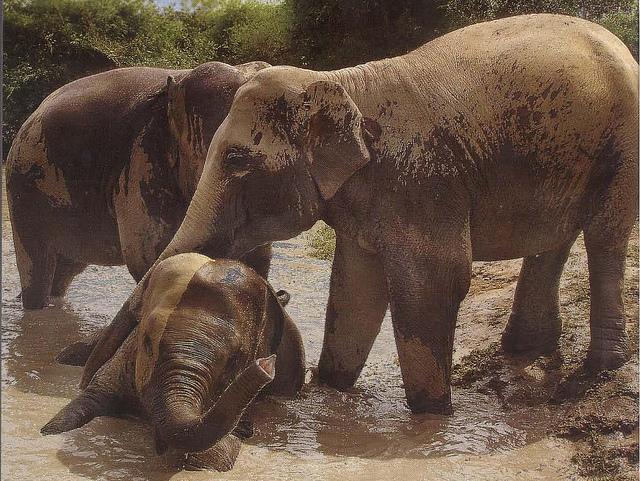Which deity looks like these animals?

Choices:
A) anubis
B) artemis
C) ganesh
D) set ganesh 